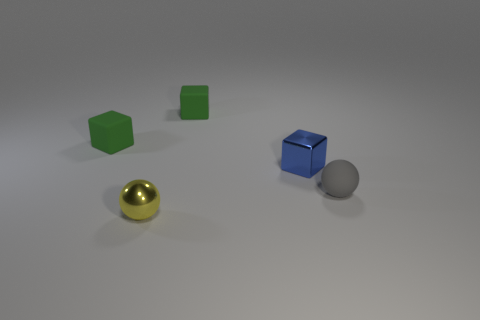Does the small metallic block have the same color as the small rubber sphere?
Keep it short and to the point. No. Are there any other things that have the same size as the blue block?
Ensure brevity in your answer.  Yes. The rubber object that is right of the tiny blue cube that is on the right side of the yellow object is what shape?
Keep it short and to the point. Sphere. Are there fewer small rubber blocks than small purple metal cylinders?
Make the answer very short. No. There is a object that is both right of the tiny shiny ball and behind the blue metallic cube; how big is it?
Give a very brief answer. Small. Is the size of the gray object the same as the blue cube?
Your answer should be compact. Yes. There is a ball in front of the gray sphere; is its color the same as the small matte ball?
Offer a very short reply. No. What number of matte objects are behind the small gray matte object?
Offer a very short reply. 2. Is the number of small blue metal things greater than the number of objects?
Your answer should be compact. No. What shape is the small rubber thing that is both on the right side of the shiny sphere and behind the small gray matte thing?
Your answer should be compact. Cube. 